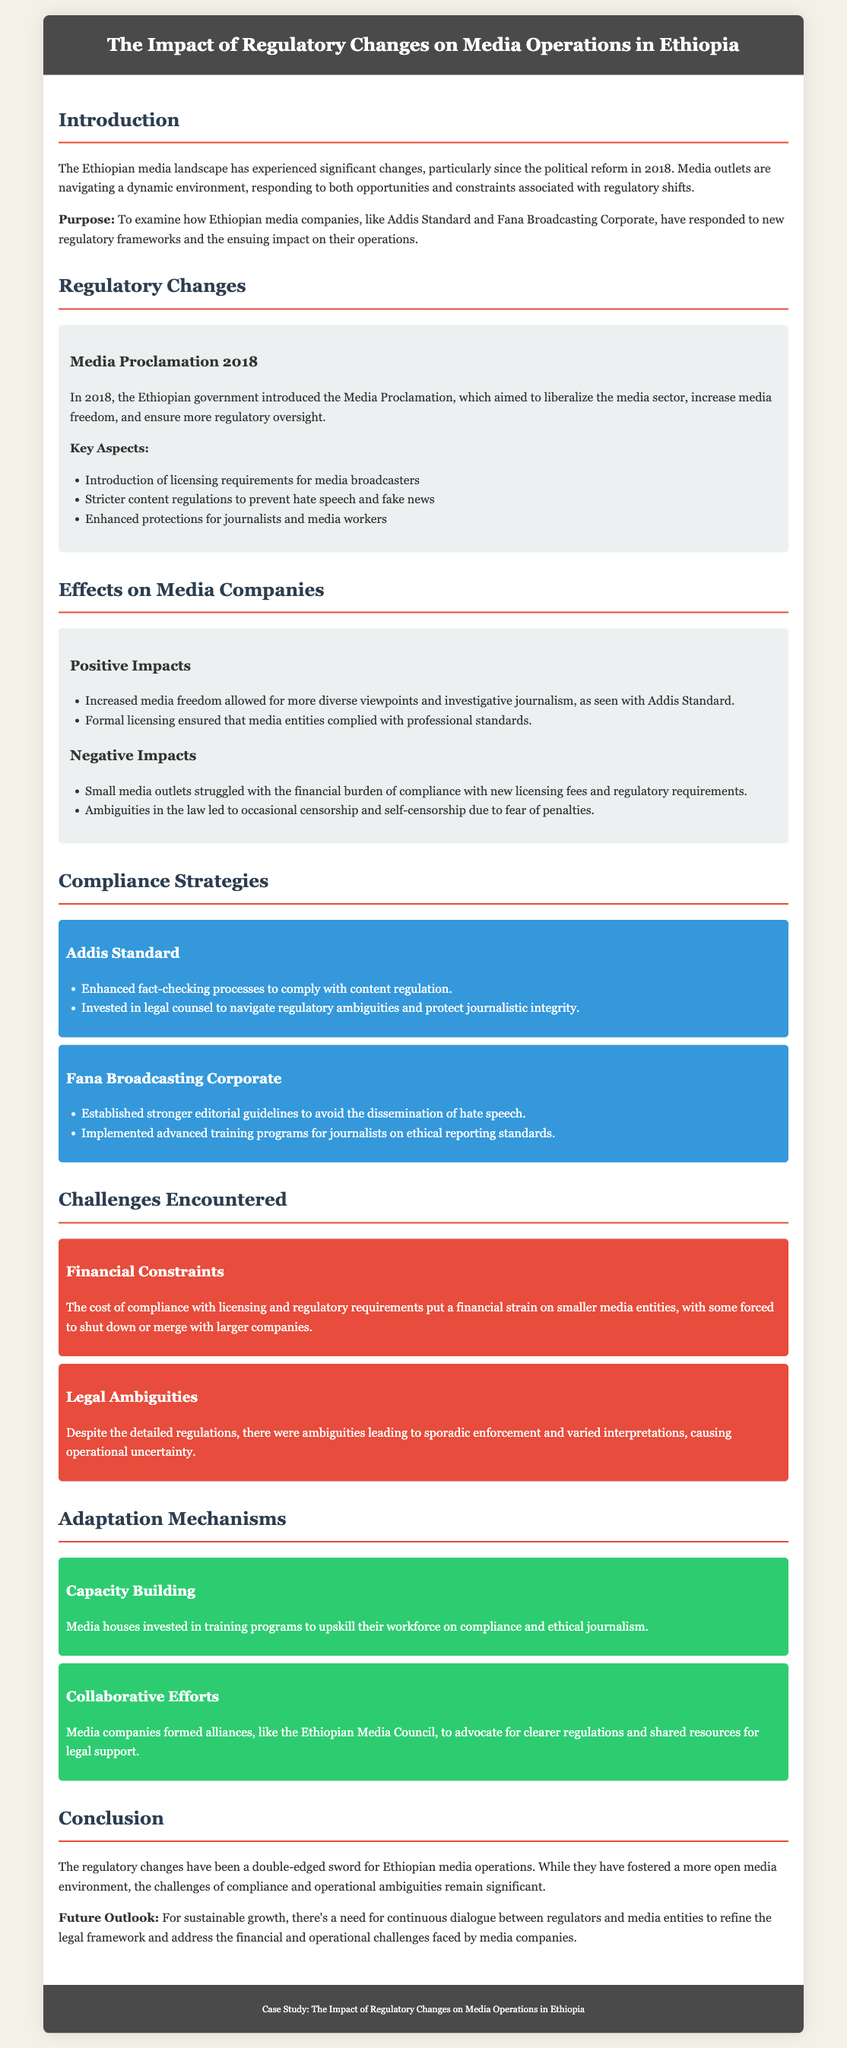What is the title of the case study? The title is explicitly stated in the header of the document, summarizing the focus on regulatory changes impacting media operations in Ethiopia.
Answer: The Impact of Regulatory Changes on Media Operations in Ethiopia What year was the Media Proclamation introduced? The document specifies that the Media Proclamation was introduced in 2018, marking a significant regulatory change.
Answer: 2018 Which company enhanced fact-checking processes as part of their compliance strategies? The document mentions that Addis Standard enhanced their fact-checking processes to align with content regulations.
Answer: Addis Standard What are two positive impacts of regulatory changes mentioned? The case study lists increased media freedom and formal licensing as positive impacts on media operations.
Answer: Increased media freedom, formal licensing What challenge did smaller media outlets face according to the case study? The text highlights financial constraints as a significant challenge for smaller media companies due to compliance costs.
Answer: Financial constraints What strategy did media houses use for workforce development? The case study states that media houses invested in training programs for capacity building within their organizations.
Answer: Training programs What was one key aspect of the Media Proclamation? The document lists the introduction of licensing requirements for media broadcasters as a key aspect of the new regulations.
Answer: Licensing requirements What is the future outlook for media companies according to the conclusion? The conclusion suggests a need for ongoing dialogue between regulators and media entities for sustainable growth.
Answer: Continuous dialogue Which organization did media companies form for legal support? The document mentions the establishment of the Ethiopian Media Council to advocate for clearer regulations and resources.
Answer: Ethiopian Media Council 